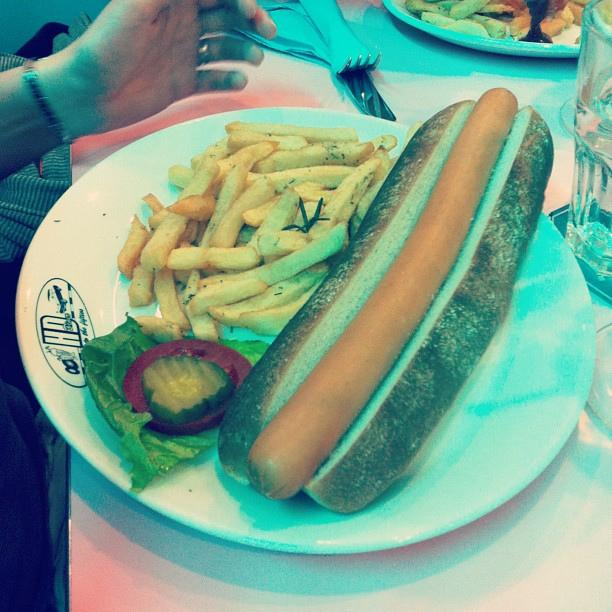Why might this longest food be unappealing to some? Please explain your reasoning. lacks condiments. There is no sauces on the hot dog. 